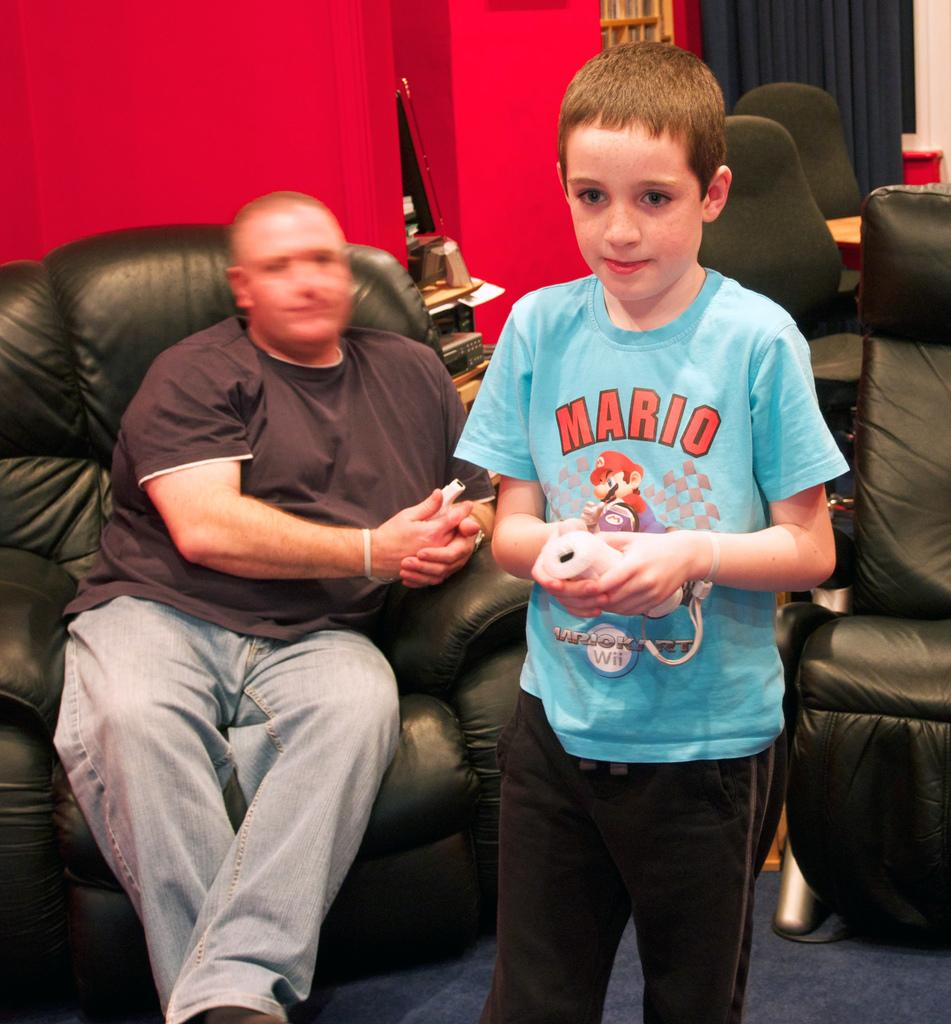What is the position of the man in the image? The man is sitting on a chair in the image. What is the boy doing in the image? The boy is standing and holding a remote in the image. What is the color of the wall in the image? The wall in the image is painted red. What type of dog is sitting next to the man in the image? There is no dog present in the image; only the man and the boy are visible. 